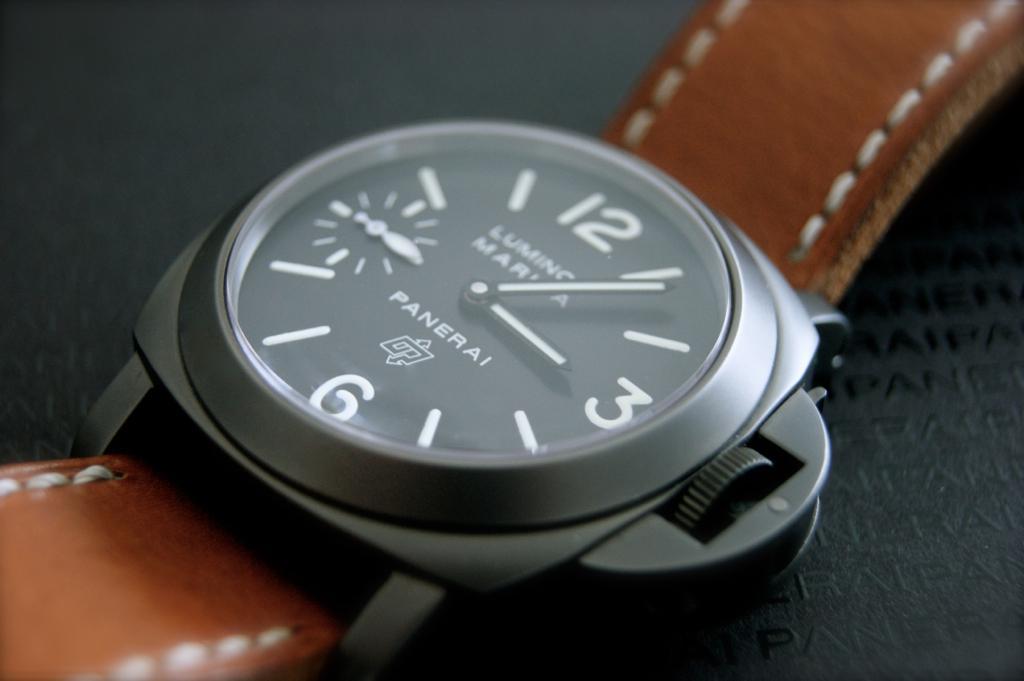Can you describe this image briefly? In the picture we can see a wrist watch with a metallic frame and leather belts which are brown in color with stitches on it and in the watch we can see a name PANERAI. 